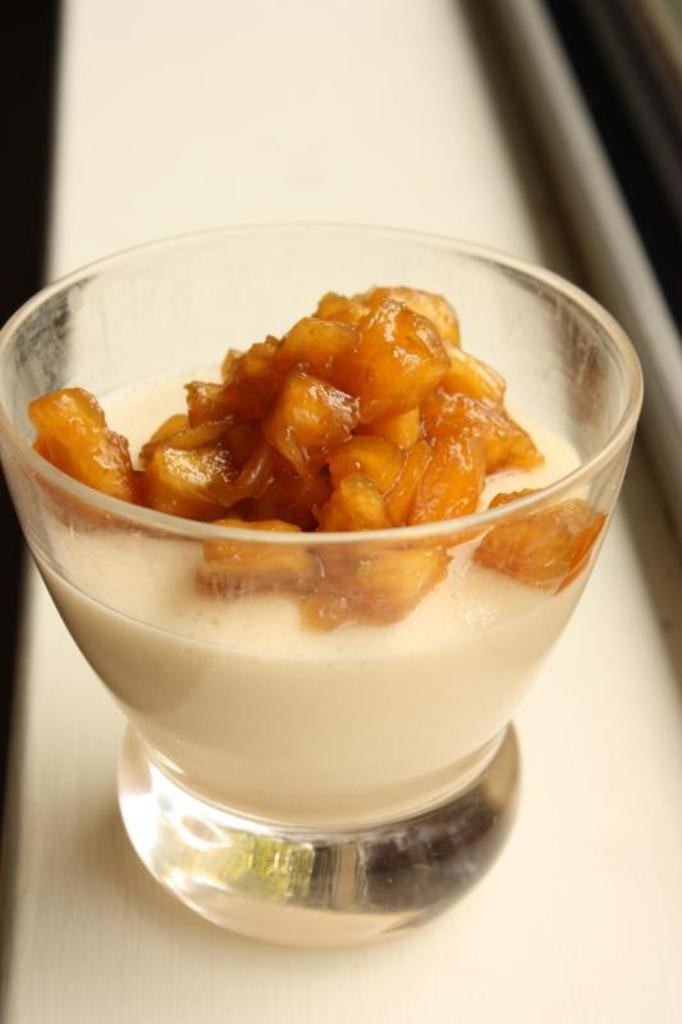What is in the bowl that is visible in the image? There is food in a bowl in the image. Where is the bowl located in the image? The bowl is on a platform in the image. How many ants are carrying the bowl in the image? There are no ants present in the image, and the bowl is not being carried. What type of motion is depicted in the image? The image does not depict any motion; it is a still image. 